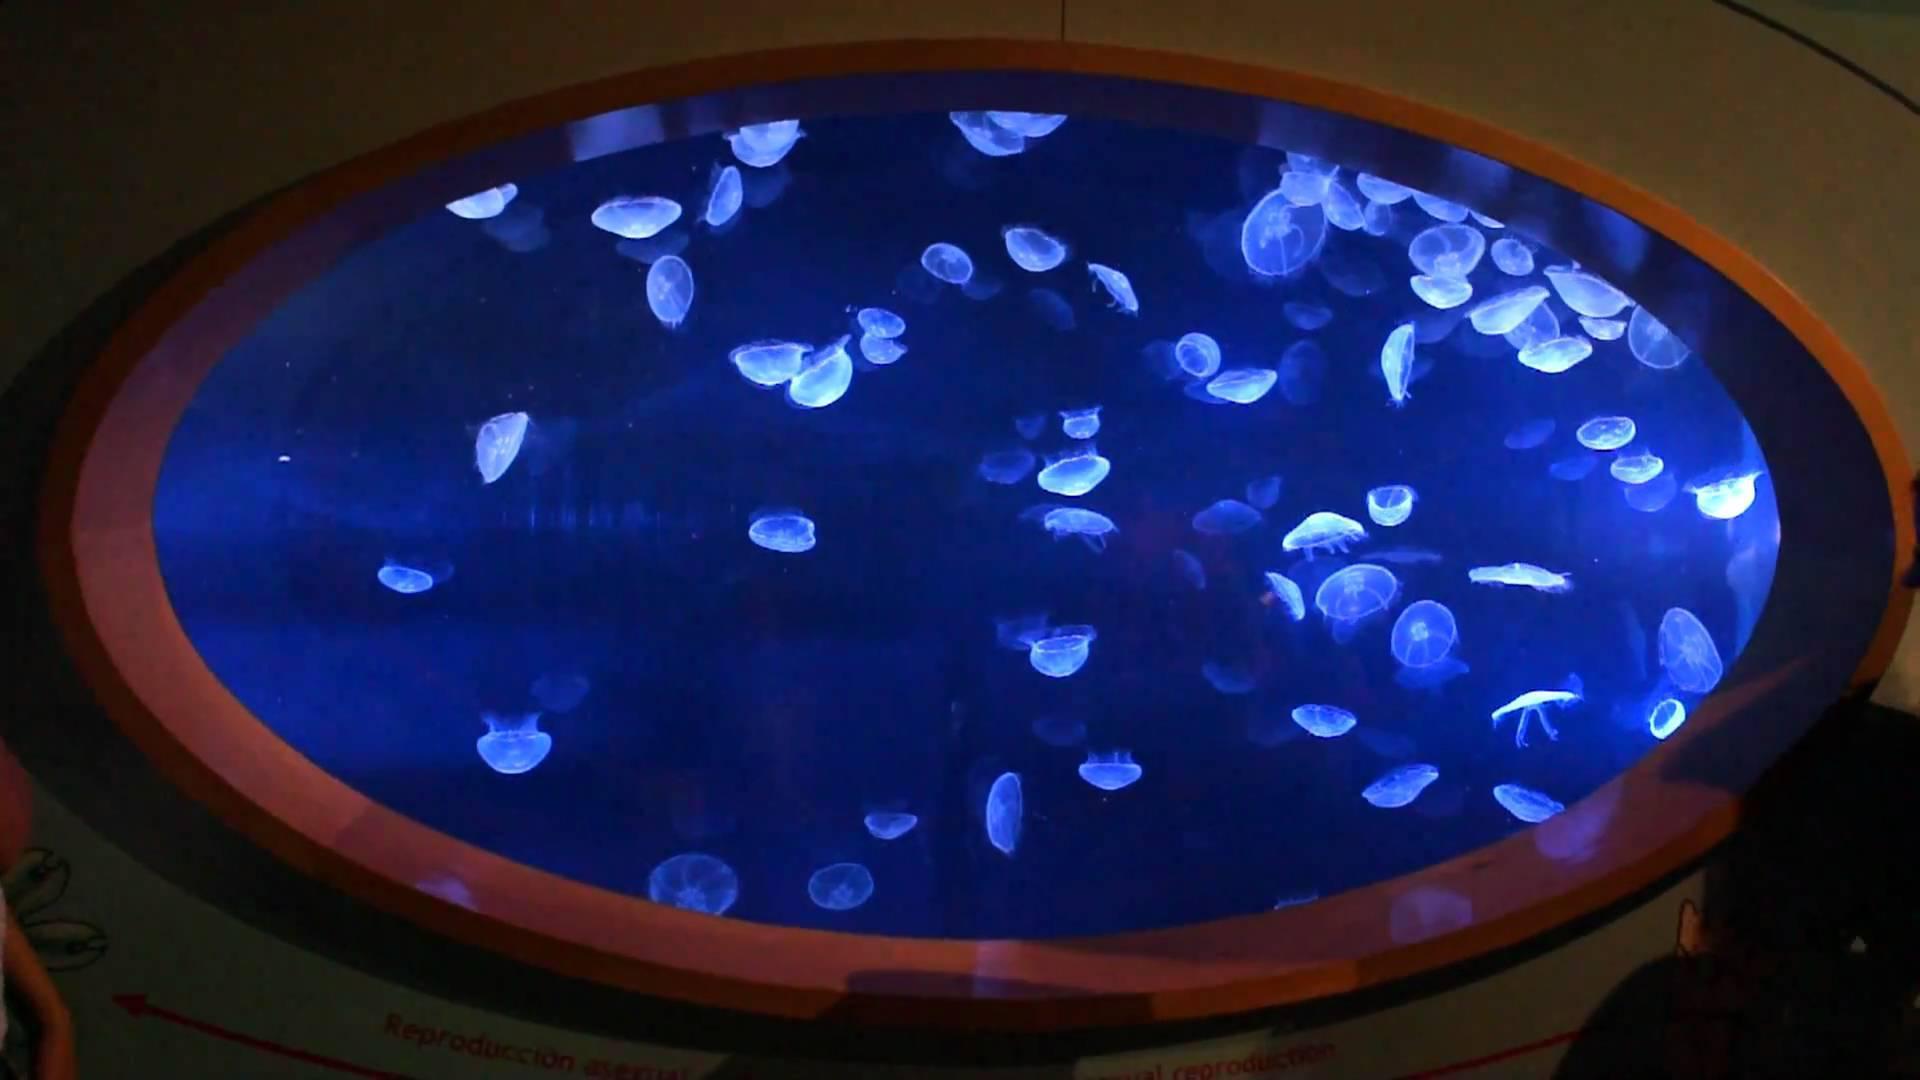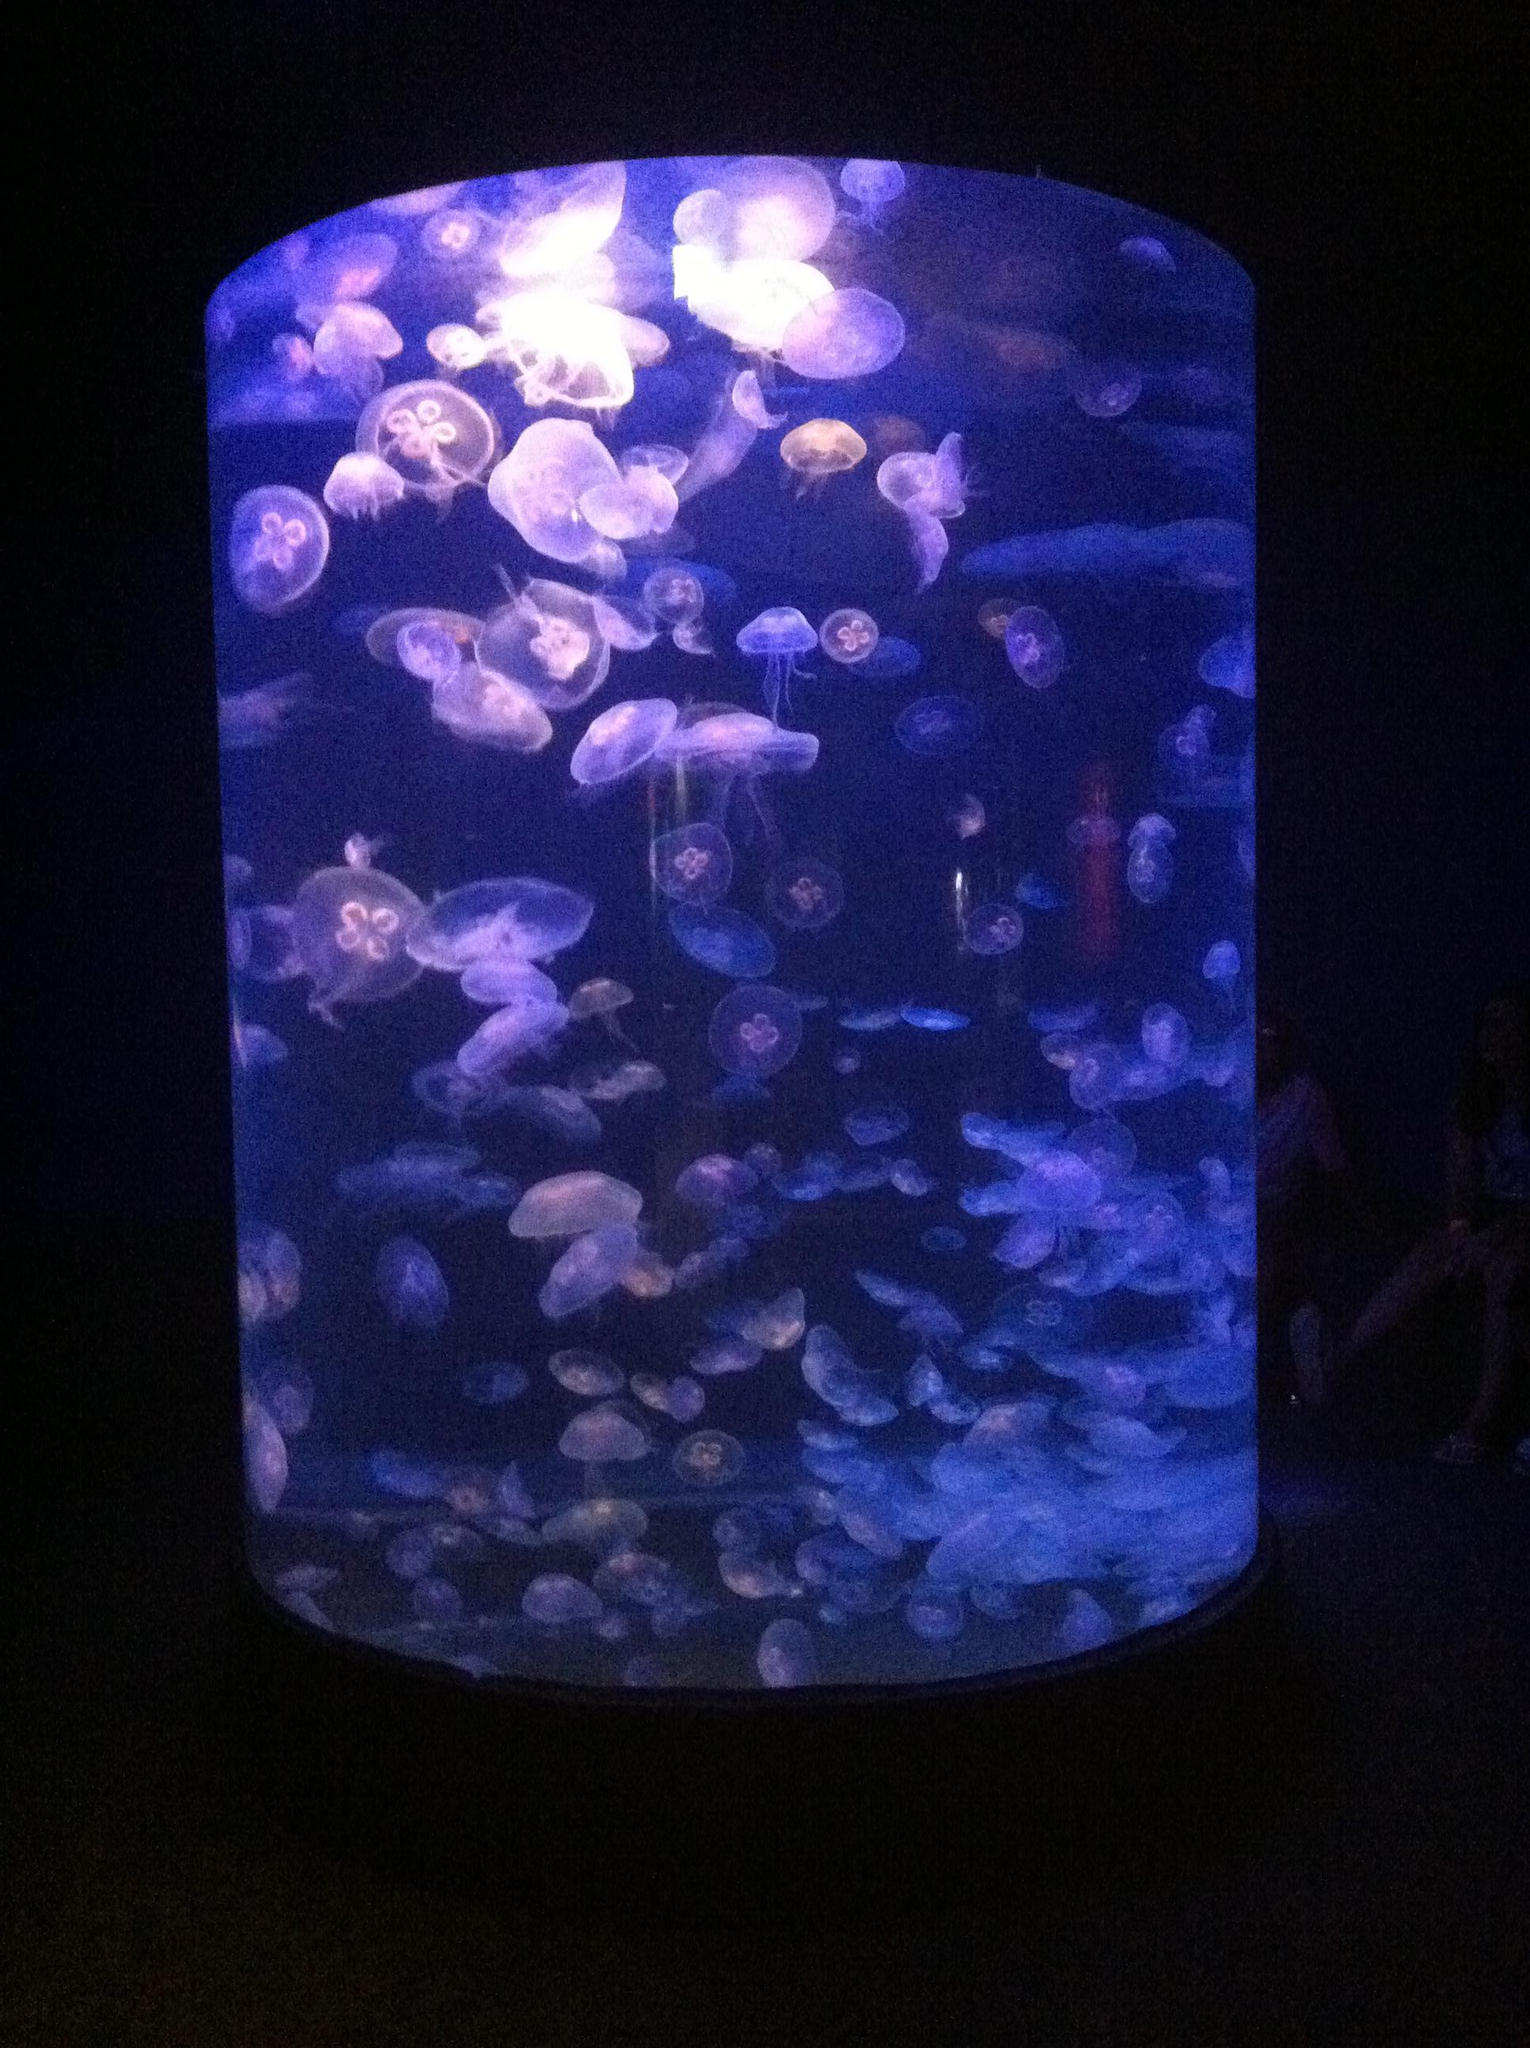The first image is the image on the left, the second image is the image on the right. Assess this claim about the two images: "Both images contain Moon Jelly jellyfish.". Correct or not? Answer yes or no. Yes. 